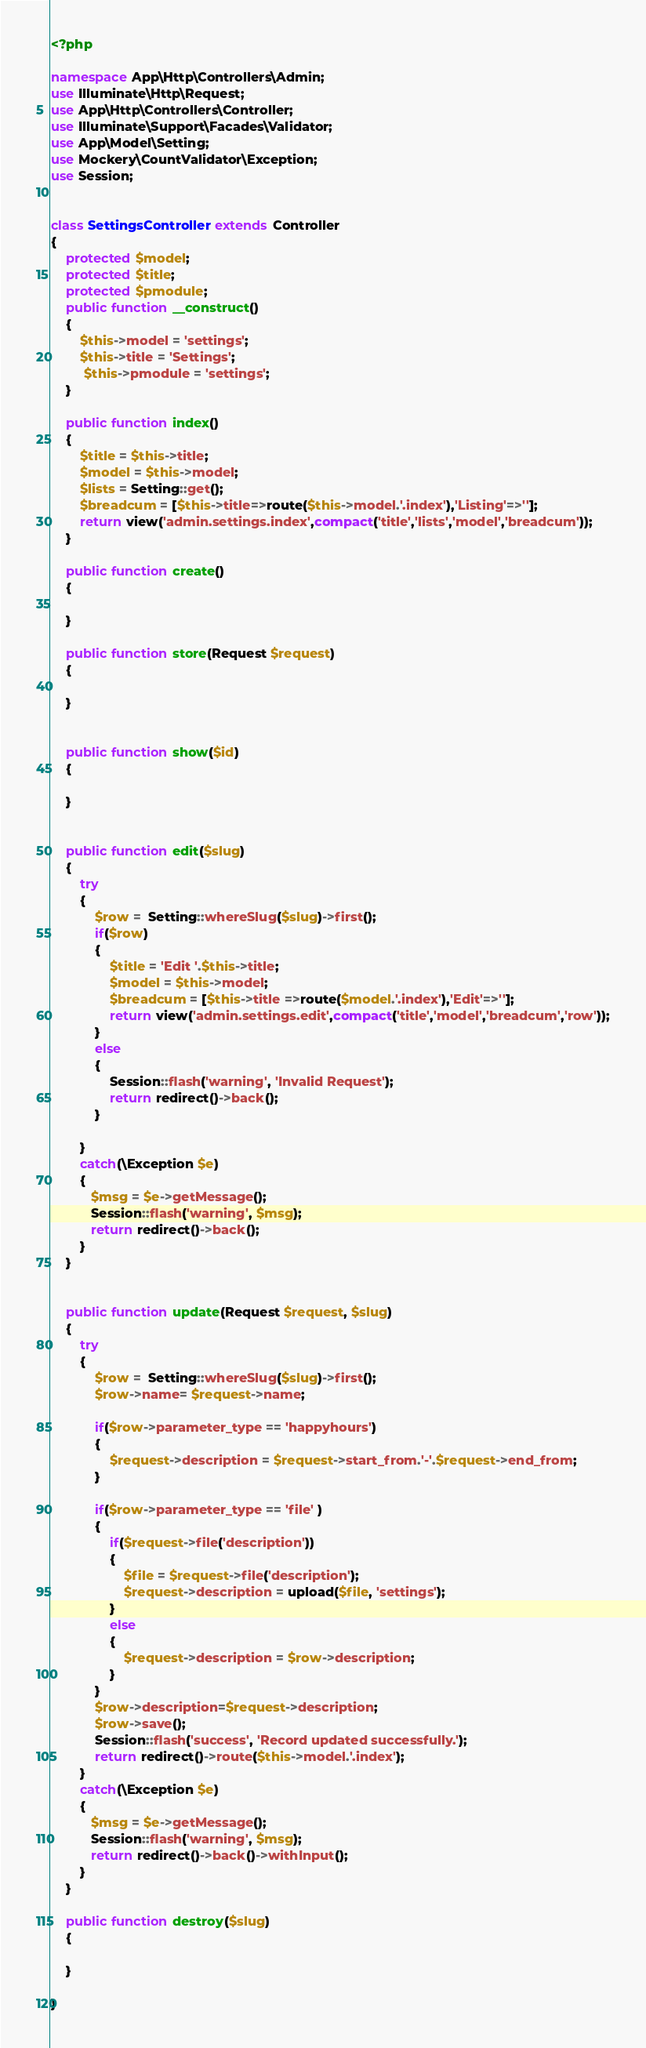Convert code to text. <code><loc_0><loc_0><loc_500><loc_500><_PHP_><?php

namespace App\Http\Controllers\Admin;
use Illuminate\Http\Request;
use App\Http\Controllers\Controller;
use Illuminate\Support\Facades\Validator;
use App\Model\Setting;
use Mockery\CountValidator\Exception;
use Session;


class SettingsController extends Controller
{
    protected $model;
    protected $title;
    protected $pmodule;
    public function __construct()
    {
        $this->model = 'settings';
        $this->title = 'Settings';
         $this->pmodule = 'settings';
    }

    public function index()
    {
        $title = $this->title;
        $model = $this->model;
        $lists = Setting::get();
        $breadcum = [$this->title=>route($this->model.'.index'),'Listing'=>''];
        return view('admin.settings.index',compact('title','lists','model','breadcum'));
    }

    public function create()
    {

    }

    public function store(Request $request)
    {

    }


    public function show($id)
    {

    }


    public function edit($slug)
    {
        try
        {
            $row =  Setting::whereSlug($slug)->first();
            if($row)
            {
                $title = 'Edit '.$this->title;
                $model = $this->model;
                $breadcum = [$this->title =>route($model.'.index'),'Edit'=>''];
                return view('admin.settings.edit',compact('title','model','breadcum','row'));
            }
            else
            {
                Session::flash('warning', 'Invalid Request');
                return redirect()->back();
            }

        }
        catch(\Exception $e)
        {
           $msg = $e->getMessage();
           Session::flash('warning', $msg);
           return redirect()->back();
        }
    }


    public function update(Request $request, $slug)
    {
        try
        {
            $row =  Setting::whereSlug($slug)->first();
            $row->name= $request->name;

            if($row->parameter_type == 'happyhours')
            {
                $request->description = $request->start_from.'-'.$request->end_from;
            }

            if($row->parameter_type == 'file' )
            {
                if($request->file('description'))
                {
                    $file = $request->file('description');
                    $request->description = upload($file, 'settings');
                }
                else
                {
                    $request->description = $row->description;
                }
            }
            $row->description=$request->description;
            $row->save();
            Session::flash('success', 'Record updated successfully.');
            return redirect()->route($this->model.'.index');
        }
        catch(\Exception $e)
        {
           $msg = $e->getMessage();
           Session::flash('warning', $msg);
           return redirect()->back()->withInput();
        }
    }

    public function destroy($slug)
    {

    }

}
</code> 